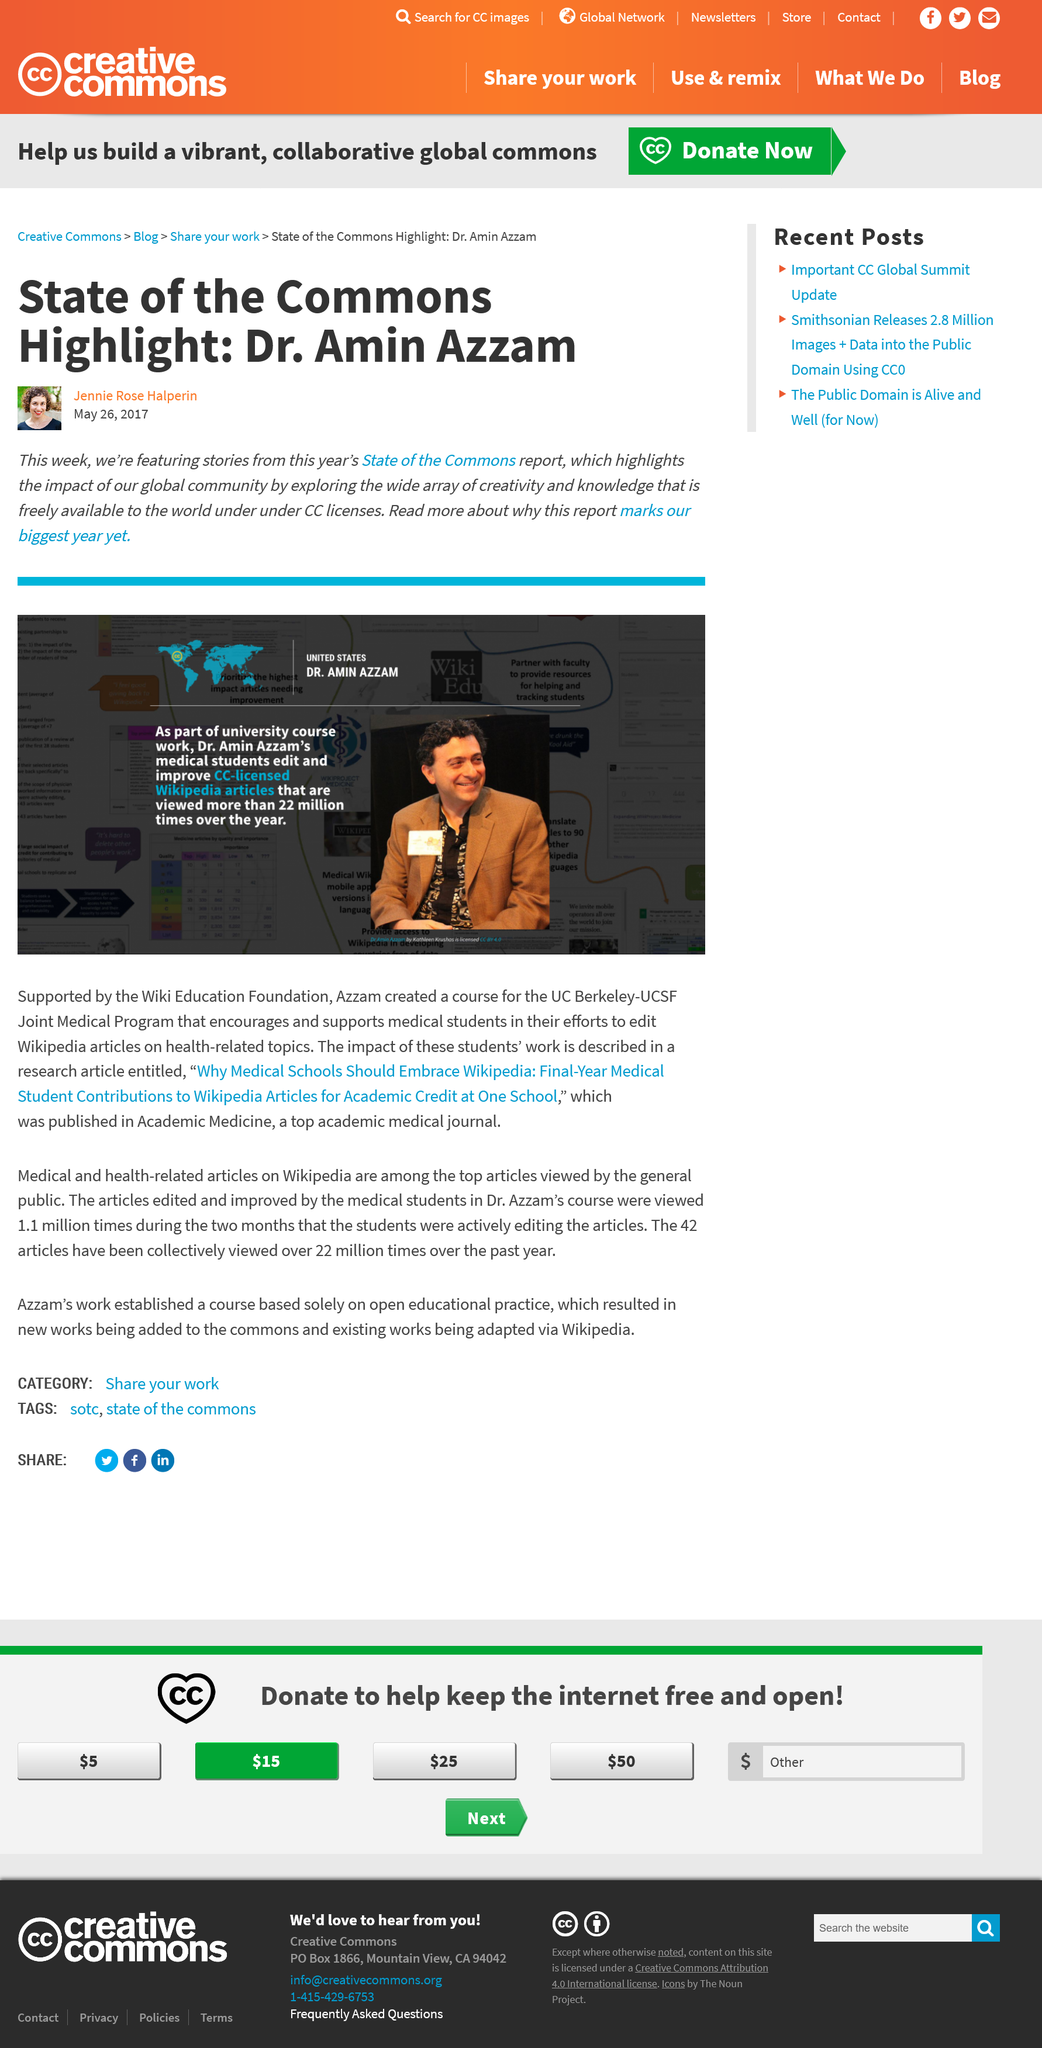Specify some key components in this picture. According to the CC-licensed Wiki articles, they have been viewed more than 22 million times annually. The article was written by Jeannie Rose Halperin on May 26, 2017. The author is writing the article about a person based in the United States. 